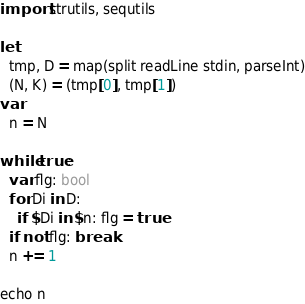Convert code to text. <code><loc_0><loc_0><loc_500><loc_500><_Nim_>import strutils, sequtils

let
  tmp, D = map(split readLine stdin, parseInt)
  (N, K) = (tmp[0], tmp[1])
var
  n = N

while true:
  var flg: bool
  for Di in D:
    if $Di in $n: flg = true
  if not flg: break
  n += 1

echo n
</code> 